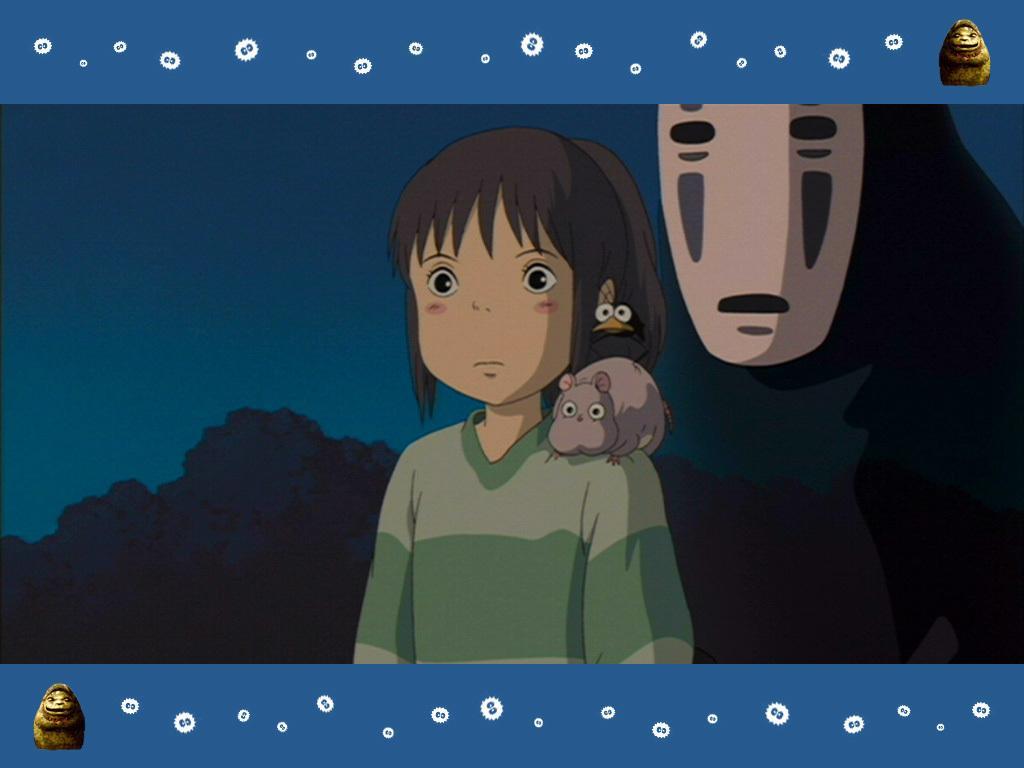Could you give a brief overview of what you see in this image? In this image I can see a cartoon character of a girl. I can also see few cartoon characters of animals. 